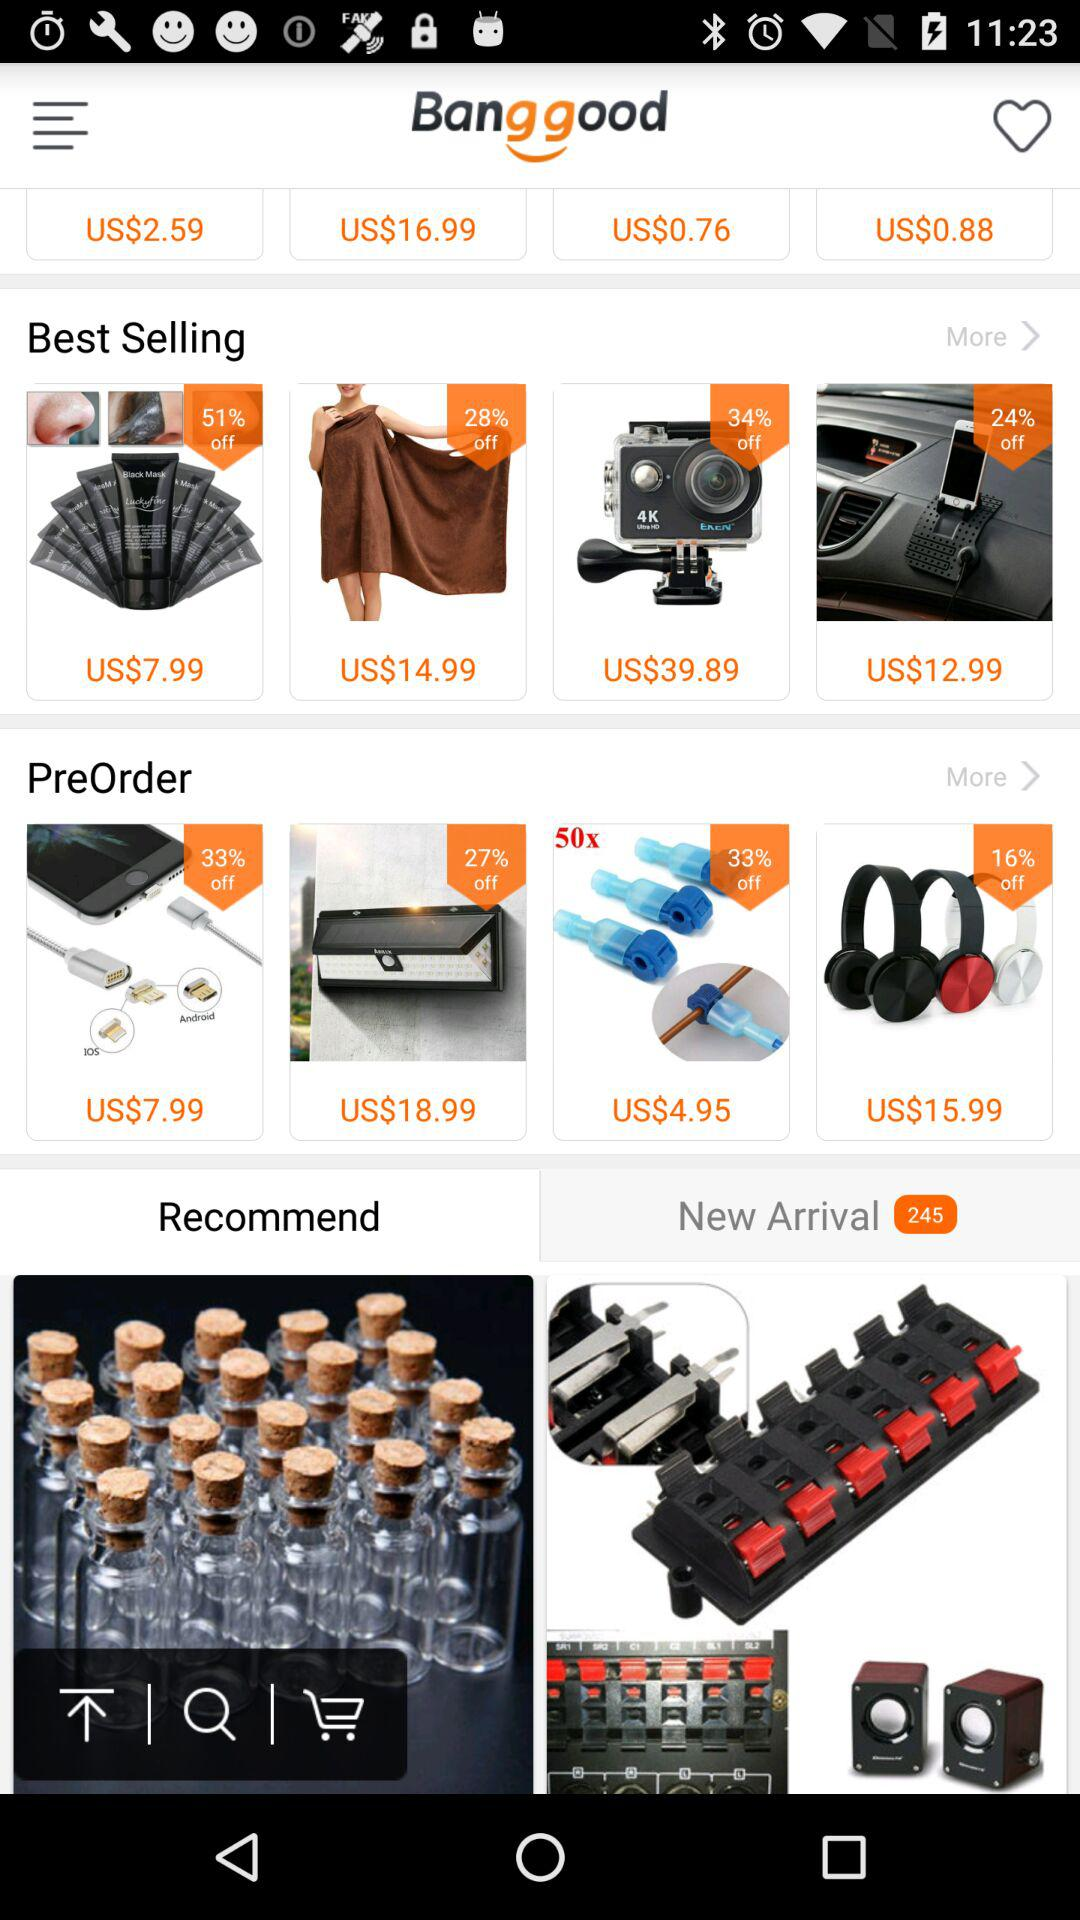What is the application name? The application name is "Bang good". 